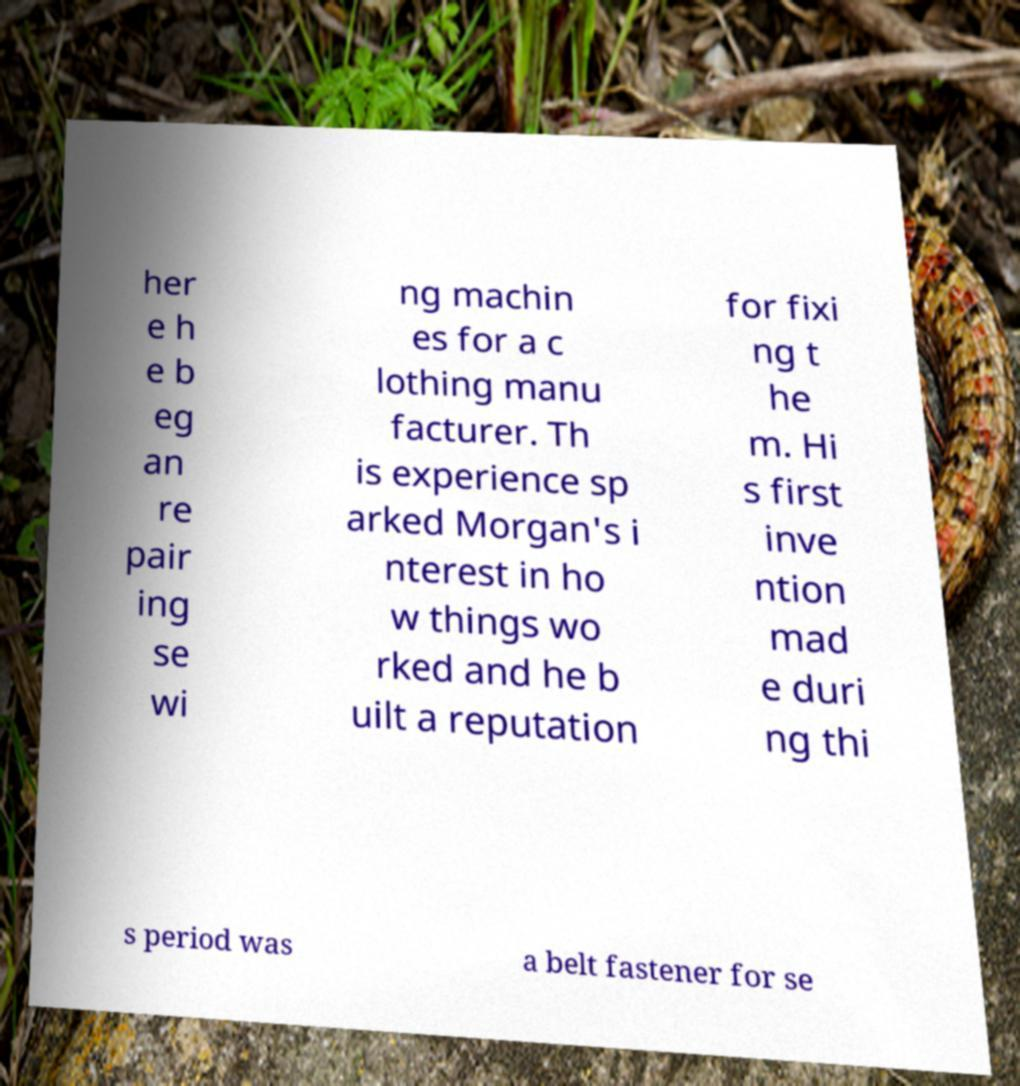Can you read and provide the text displayed in the image?This photo seems to have some interesting text. Can you extract and type it out for me? her e h e b eg an re pair ing se wi ng machin es for a c lothing manu facturer. Th is experience sp arked Morgan's i nterest in ho w things wo rked and he b uilt a reputation for fixi ng t he m. Hi s first inve ntion mad e duri ng thi s period was a belt fastener for se 